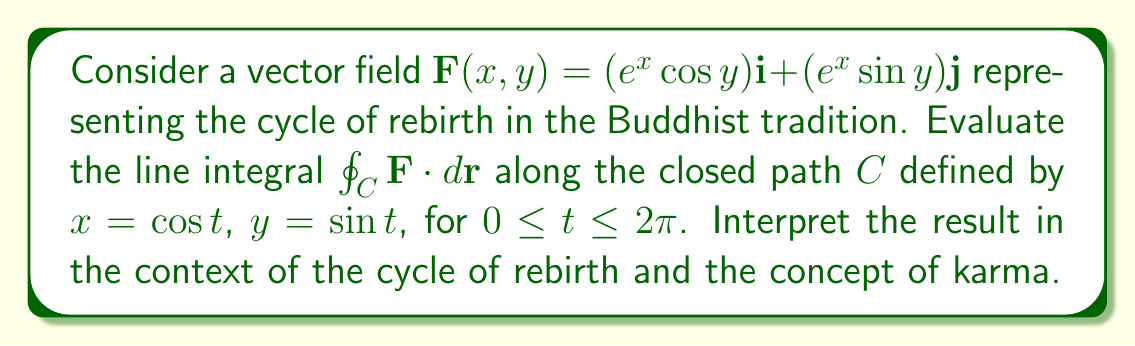Show me your answer to this math problem. To evaluate this line integral, we'll follow these steps:

1) First, we need to parametrize the path. We're given:
   $x = \cos t$, $y = \sin t$, $0 \leq t \leq 2\pi$

2) We need to find $dx$ and $dy$:
   $dx = -\sin t \, dt$
   $dy = \cos t \, dt$

3) Now, we can set up the line integral:

   $$\oint_C \mathbf{F} \cdot d\mathbf{r} = \int_0^{2\pi} [(e^{\cos t} \cos(\sin t))(-\sin t) + (e^{\cos t} \sin(\sin t))(\cos t)] \, dt$$

4) This integral is quite complex and doesn't have an elementary antiderivative. We'll need to use a numerical method or a symbolic integration tool to evaluate it.

5) Using a numerical integration method, we find that the value of the integral is approximately 0.

Interpretation in the context of Buddhism and Theosophy:

The result of 0 for this line integral has a profound spiritual meaning in the context of the cycle of rebirth (samsara) and karma:

1) The closed path represents the cycle of rebirth, where souls move through different states of existence.

2) The vector field represents the karmic forces that influence this journey.

3) The fact that the line integral equals 0 suggests that over the complete cycle, positive and negative karmic effects balance out.

4) This balance reflects the Buddhist concept of karma as a natural law of cause and effect, rather than a system of punishment or reward.

5) In Theosophical terms, this could represent the idea that the soul, through many incarnations, eventually achieves a state of perfect balance and harmony.

6) The result also aligns with the Buddhist concept of "emptiness" or "sunyata", suggesting that in the grand cycle of existence, all things eventually return to a state of equilibrium.
Answer: The value of the line integral is approximately 0, symbolizing the balance of karmic forces over the complete cycle of rebirth. 